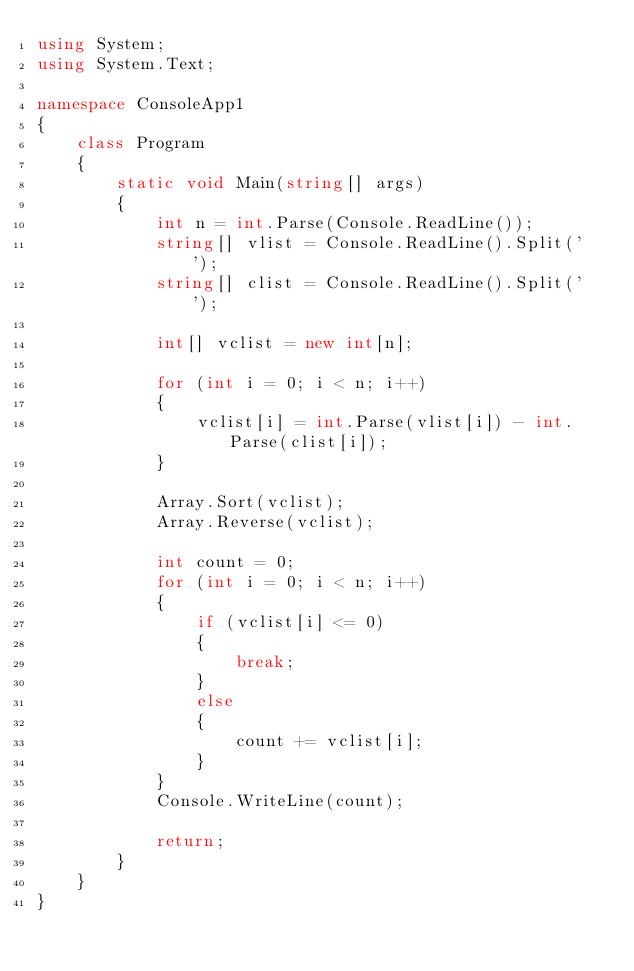<code> <loc_0><loc_0><loc_500><loc_500><_C#_>using System;
using System.Text;

namespace ConsoleApp1
{
    class Program
    {
        static void Main(string[] args)
        {
            int n = int.Parse(Console.ReadLine());
            string[] vlist = Console.ReadLine().Split(' ');
            string[] clist = Console.ReadLine().Split(' ');

            int[] vclist = new int[n];

            for (int i = 0; i < n; i++)
            {
                vclist[i] = int.Parse(vlist[i]) - int.Parse(clist[i]);
            }
            
            Array.Sort(vclist);
            Array.Reverse(vclist);

            int count = 0;
            for (int i = 0; i < n; i++)
            {
                if (vclist[i] <= 0)
                {
                    break;
                }
                else
                {
                    count += vclist[i];
                }
            }
            Console.WriteLine(count);

            return;
        }
    }
}</code> 